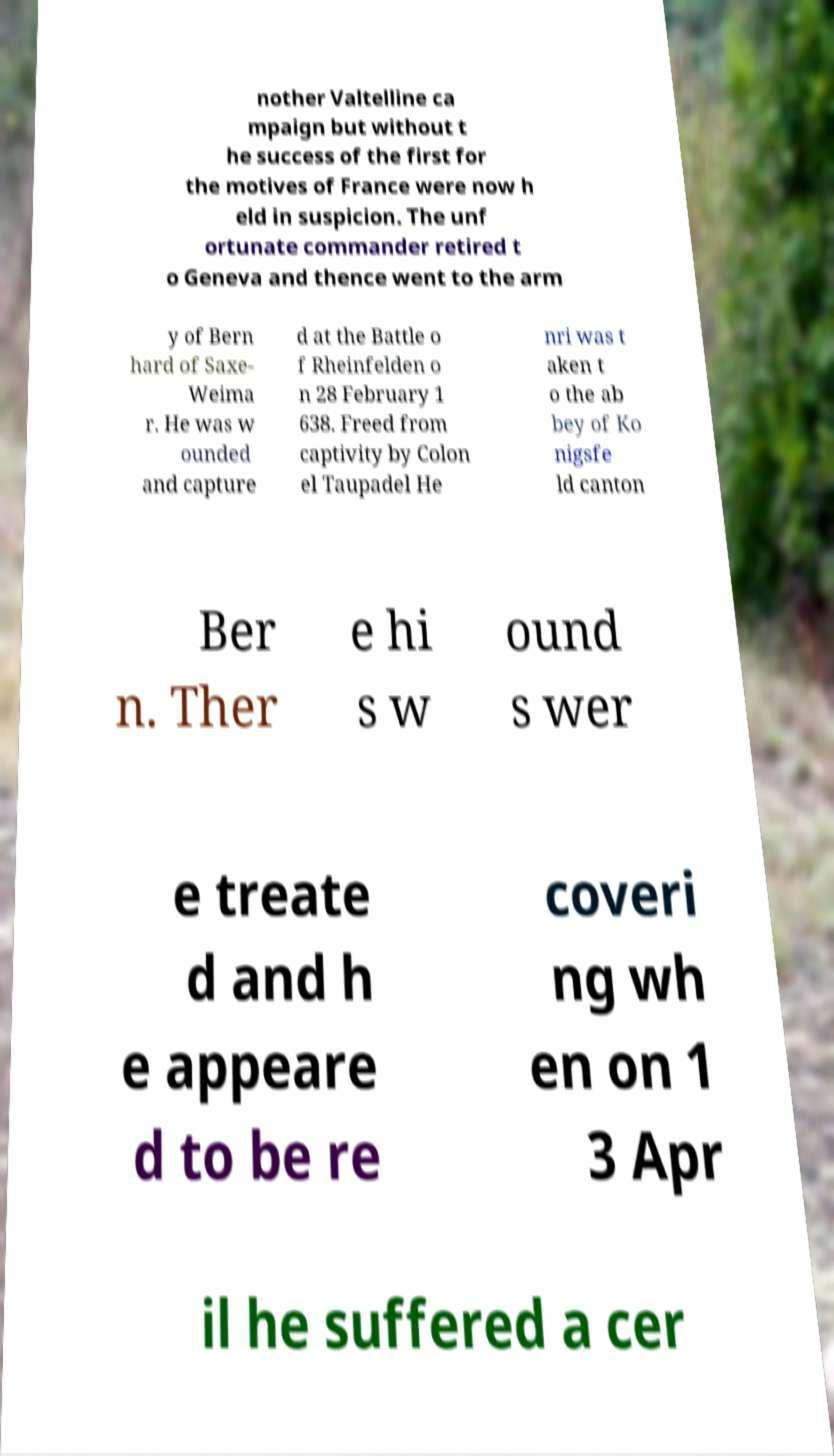For documentation purposes, I need the text within this image transcribed. Could you provide that? nother Valtelline ca mpaign but without t he success of the first for the motives of France were now h eld in suspicion. The unf ortunate commander retired t o Geneva and thence went to the arm y of Bern hard of Saxe- Weima r. He was w ounded and capture d at the Battle o f Rheinfelden o n 28 February 1 638. Freed from captivity by Colon el Taupadel He nri was t aken t o the ab bey of Ko nigsfe ld canton Ber n. Ther e hi s w ound s wer e treate d and h e appeare d to be re coveri ng wh en on 1 3 Apr il he suffered a cer 